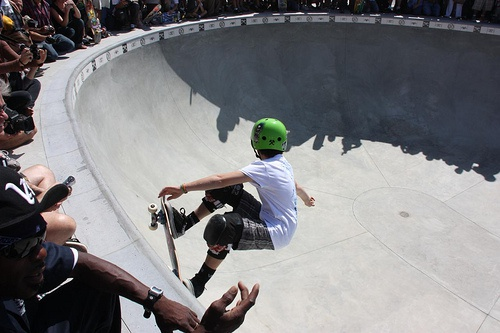Describe the objects in this image and their specific colors. I can see people in black, lightgray, brown, and maroon tones, people in black, lightgray, gray, and darkgray tones, people in black, lightgray, tan, and gray tones, people in black, gray, maroon, and lightgray tones, and people in black, gray, and maroon tones in this image. 